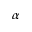<formula> <loc_0><loc_0><loc_500><loc_500>\alpha</formula> 